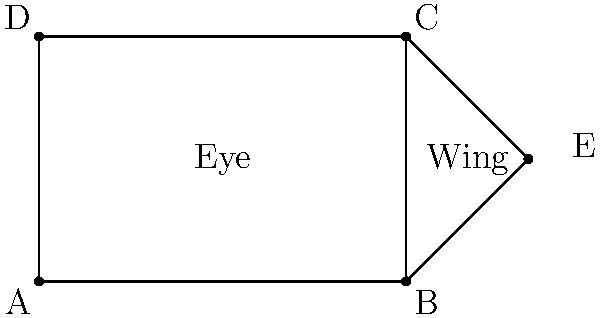In creating the perfect winged eyeliner, you decide to use geometric shapes for precision. If the eye is represented by a rectangle ABCD and the wing is formed by triangle BCE, what is the ratio of the area of the wing (triangle BCE) to the area of the eye (rectangle ABCD) if BE = EC and BE = 1.5 units? Let's approach this step-by-step:

1) First, we need to calculate the area of rectangle ABCD (the eye):
   Area of rectangle = length × width
   Length (AB) = 3 units
   Width (BC) = 2 units
   Area of eye = $3 \times 2 = 6$ square units

2) Now, let's calculate the area of triangle BCE (the wing):
   We know that BE = EC = 1.5 units
   The base of the triangle (BC) is 2 units (same as the width of the rectangle)
   
   To find the height of the triangle, we can use the Pythagorean theorem:
   $BE^2 = (\text{height})^2 + (BC/2)^2$
   $1.5^2 = h^2 + 1^2$
   $2.25 = h^2 + 1$
   $h^2 = 1.25$
   $h = \sqrt{1.25} \approx 1.118$ units

3) Now we can calculate the area of the triangle:
   Area of triangle = $\frac{1}{2} \times$ base $\times$ height
   Area of wing = $\frac{1}{2} \times 2 \times 1.118 = 1.118$ square units

4) The ratio of the wing area to the eye area is:
   $\frac{\text{Area of wing}}{\text{Area of eye}} = \frac{1.118}{6} \approx 0.186$

5) This can be simplified to $\frac{1.118}{6} = \frac{559}{3000}$
Answer: $\frac{559}{3000}$ 